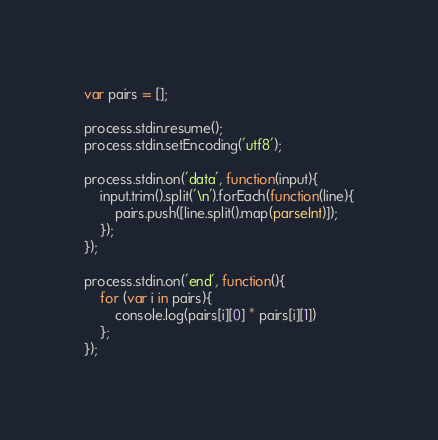Convert code to text. <code><loc_0><loc_0><loc_500><loc_500><_JavaScript_>var pairs = [];

process.stdin.resume();
process.stdin.setEncoding('utf8');

process.stdin.on('data', function(input){
    input.trim().split('\n').forEach(function(line){
        pairs.push([line.split().map(parseInt)]);
    });
});

process.stdin.on('end', function(){
    for (var i in pairs){
        console.log(pairs[i][0] * pairs[i][1])
    };
});</code> 